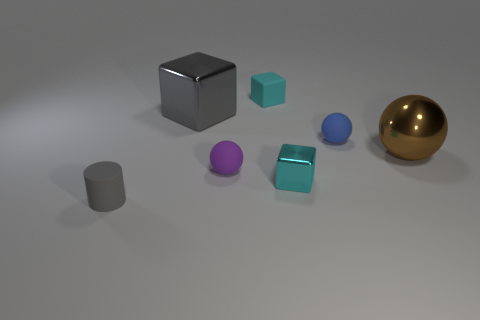There is another tiny rubber thing that is the same shape as the small blue object; what is its color?
Make the answer very short. Purple. There is a shiny sphere; is it the same color as the rubber cylinder in front of the blue object?
Provide a succinct answer. No. What shape is the tiny object that is both on the right side of the tiny matte block and in front of the tiny blue thing?
Offer a very short reply. Cube. Are there fewer large metal blocks than tiny balls?
Provide a short and direct response. Yes. Are any purple rubber spheres visible?
Make the answer very short. Yes. How many other things are the same size as the cyan metal thing?
Your answer should be compact. 4. Does the tiny cylinder have the same material as the sphere that is behind the metallic ball?
Your answer should be compact. Yes. Are there an equal number of things that are behind the big brown metal ball and things that are to the left of the rubber cube?
Your answer should be compact. Yes. What material is the large gray cube?
Ensure brevity in your answer.  Metal. What is the color of the other metal object that is the same size as the blue object?
Your response must be concise. Cyan. 